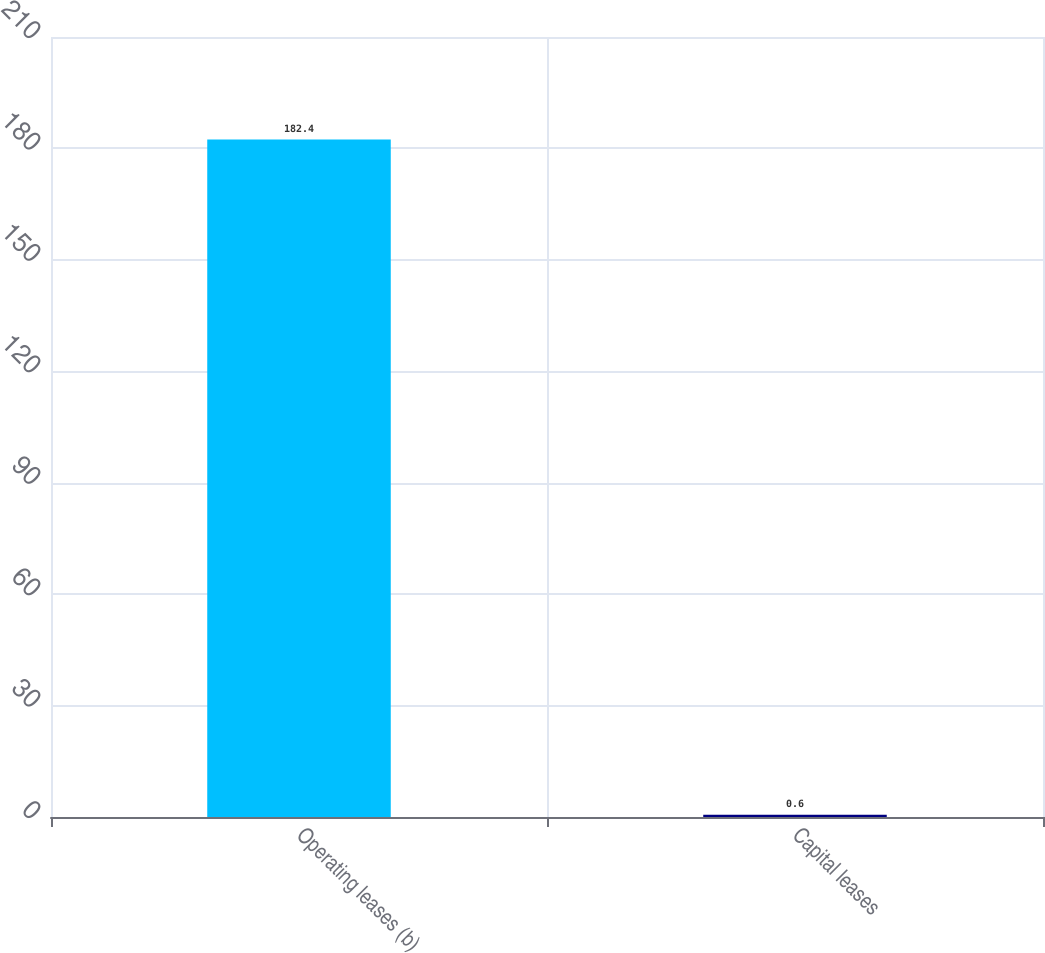Convert chart to OTSL. <chart><loc_0><loc_0><loc_500><loc_500><bar_chart><fcel>Operating leases (b)<fcel>Capital leases<nl><fcel>182.4<fcel>0.6<nl></chart> 